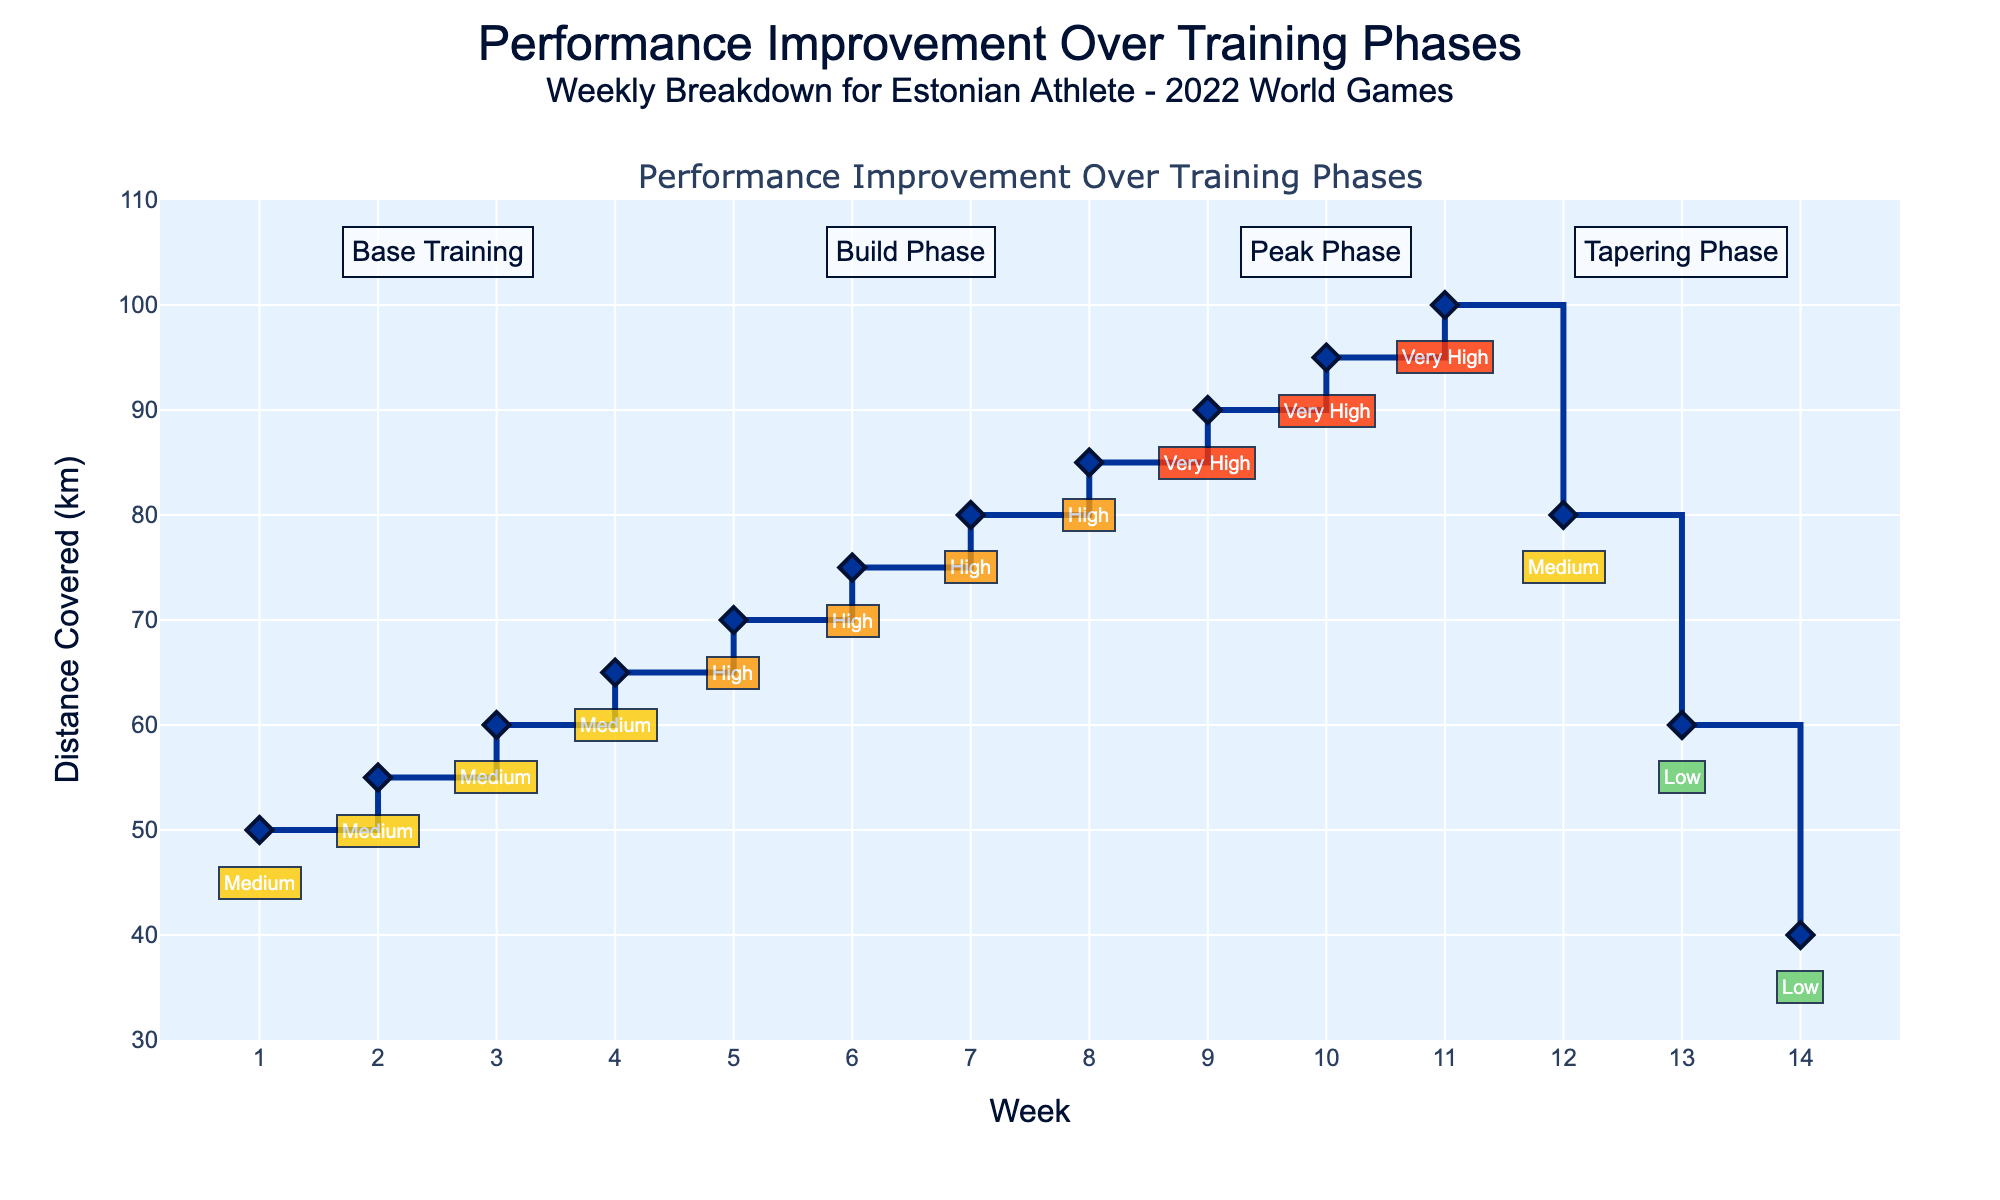What's the title of the figure? The title is usually prominently displayed at the top of the figure.
Answer: Performance Improvement Over Training Phases - Weekly Breakdown for Estonian Athlete - 2022 World Games What is the distance covered in week 7? Locate week 7 on the x-axis and find the corresponding data point on the y-axis for "Distance Covered (km)".
Answer: 80 km Which phase has the highest intensity level? The intensity levels are annotated near the data points, and the phase with "Very High" as the intensity level is the one with the highest intensity.
Answer: Peak Phase Compare the distance covered between the first and last week. Check the distance covered in week 1 and week 14 on the y-axis. Week 1 shows 50 km, and week 14 shows 40 km.
Answer: 10 km decrease During which weeks do we see a transition from "High" to "Very High" intensity? Identify weeks with "High" intensity and the weeks following them that have "Very High" intensity.
Answer: Week 8 to Week 9 What is the total distance covered during the Build Phase? Sum up the distances covered in weeks 5, 6, 7, and 8. (70 km + 75 km + 80 km + 85 km)
Answer: 310 km On which weeks is the intensity level marked as "Low"? Identify the weeks with "Low" intensity based on the annotations on or near the data points.
Answer: Weeks 13 and 14 Which week has the greatest increase in distance covered compared to the previous week? Determine the weekly differences and find the week with the largest positive difference.
Answer: Week 4 to Week 5 (5 km increase) How does the distance trend change during the Tapering Phase? Observe the pattern in distance covered from week 12 to 14; it decreases each week.
Answer: Decreases What is the average distance covered during the Peak Phase? Sum the distances covered in weeks 9, 10, and 11 and divide by 3. (90 km + 95 km + 100 km) / 3
Answer: 95 km 